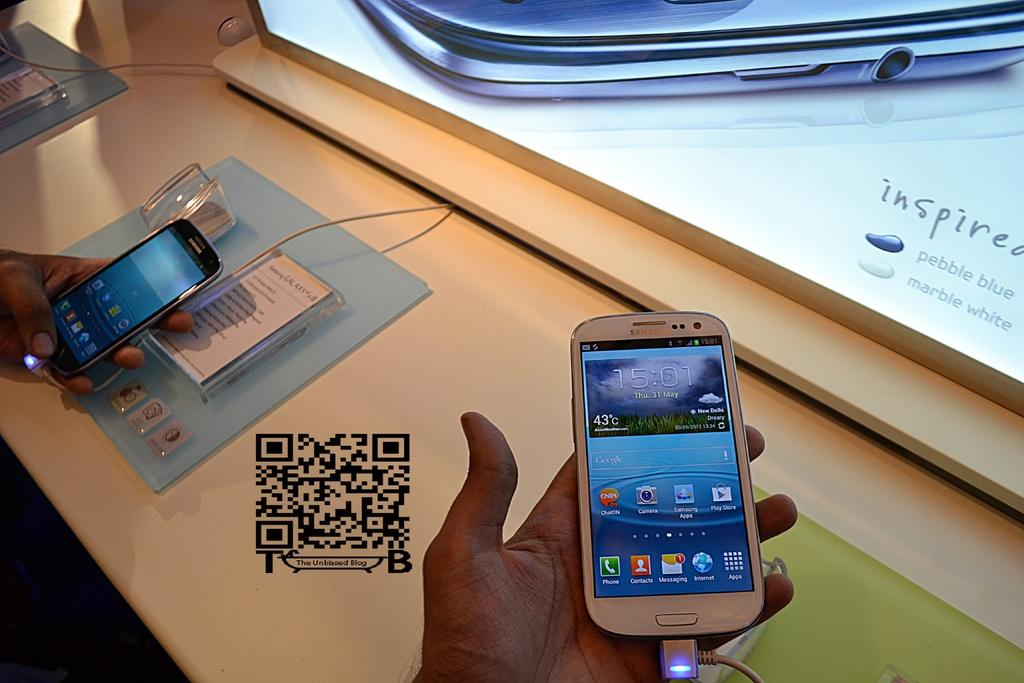<image>
Summarize the visual content of the image. The phone indicates this picture was taken on Thursday, May 31st. 